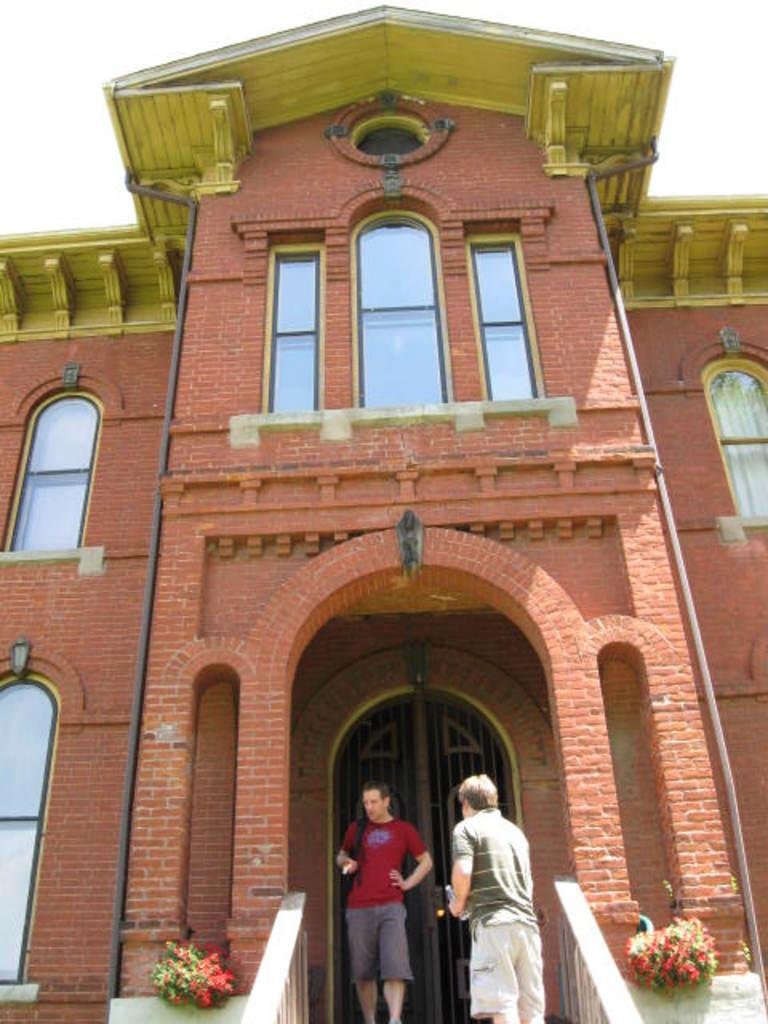What is the main structure in the image? There is a building in the image. Who or what is in front of the building? Two persons are standing in front of the building. What type of vegetation is present in the image? There are plants with flowers in the image. What color is the background of the image? The background of the image is white. What type of horn can be seen on the building in the image? There is no horn present on the building in the image. What is the material of the sheet covering the flowers in the image? There is no sheet covering the flowers in the image; the plants with flowers are visible. 